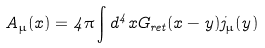Convert formula to latex. <formula><loc_0><loc_0><loc_500><loc_500>A _ { \mu } ( x ) = 4 \pi \int d ^ { 4 } x G _ { r e t } ( x - y ) j _ { \mu } ( y )</formula> 